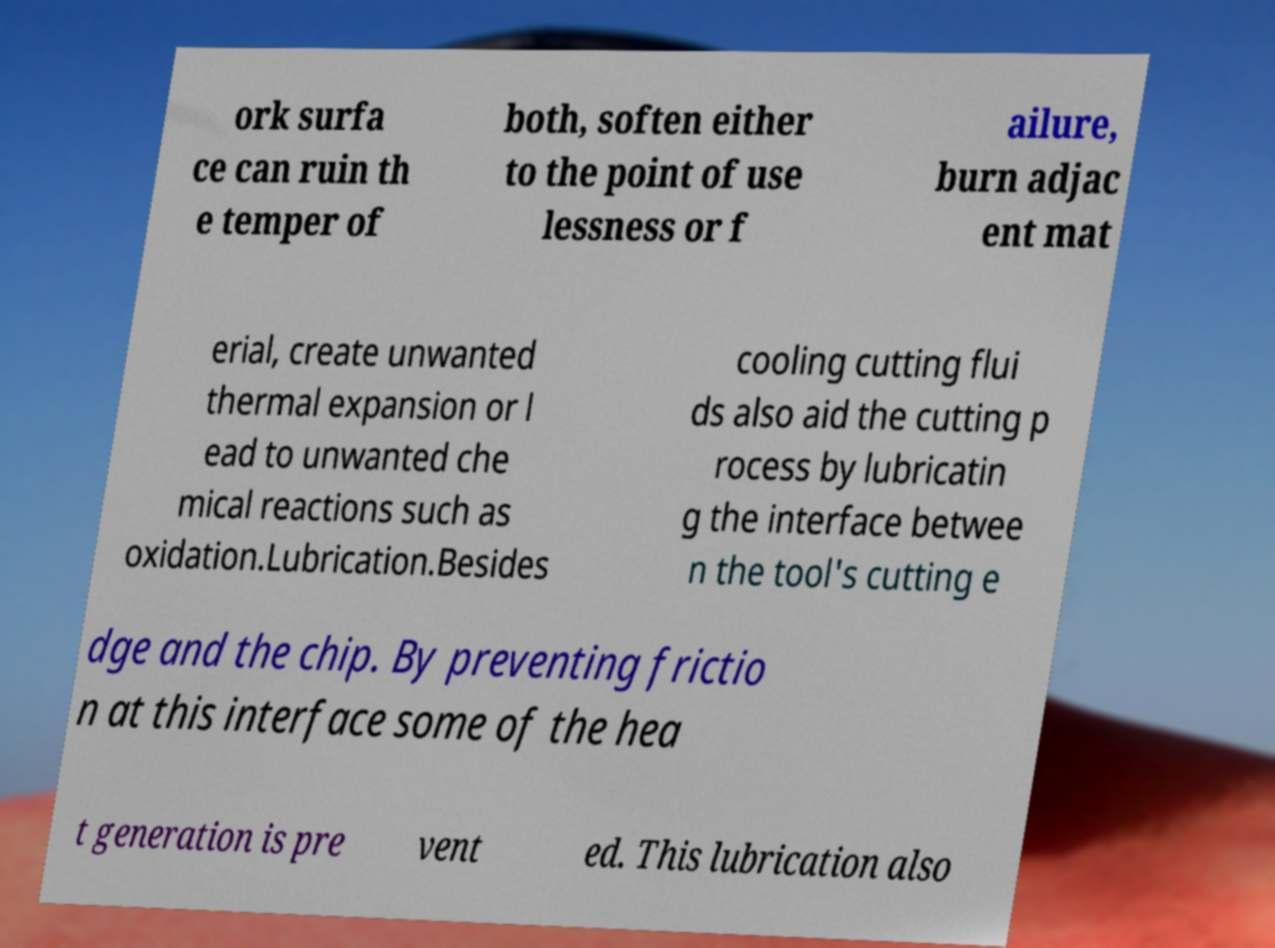What messages or text are displayed in this image? I need them in a readable, typed format. ork surfa ce can ruin th e temper of both, soften either to the point of use lessness or f ailure, burn adjac ent mat erial, create unwanted thermal expansion or l ead to unwanted che mical reactions such as oxidation.Lubrication.Besides cooling cutting flui ds also aid the cutting p rocess by lubricatin g the interface betwee n the tool's cutting e dge and the chip. By preventing frictio n at this interface some of the hea t generation is pre vent ed. This lubrication also 